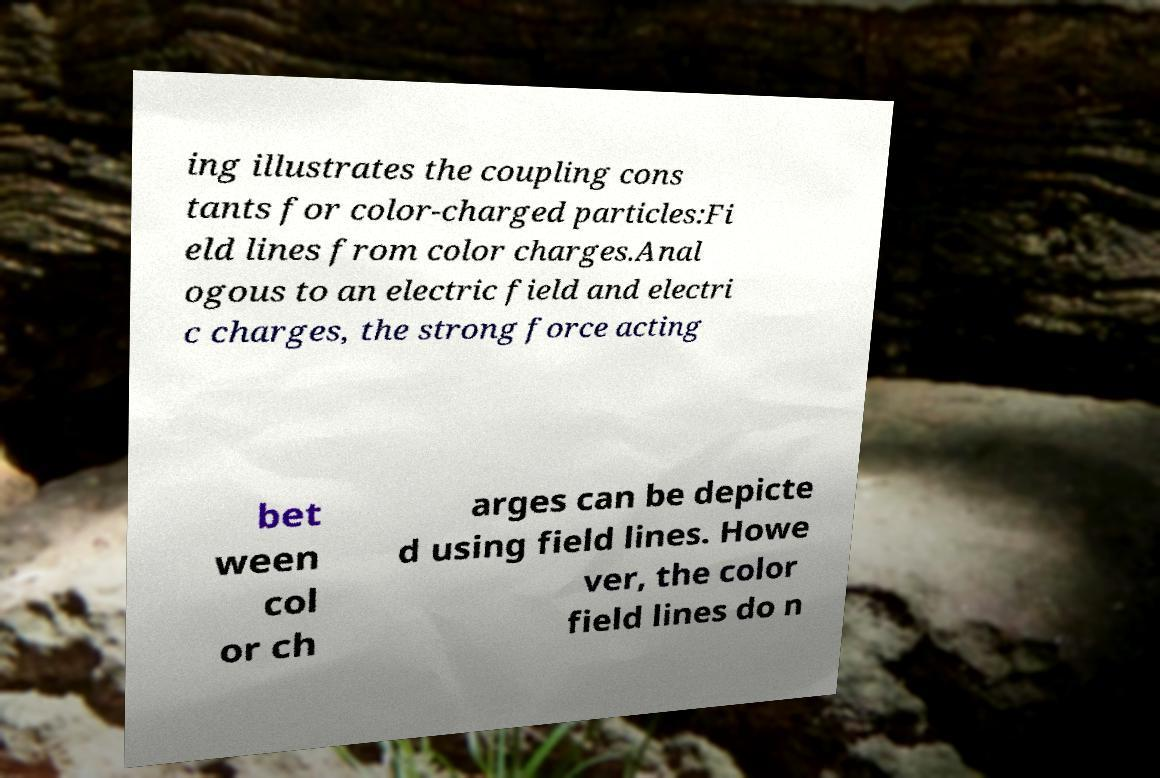Could you extract and type out the text from this image? ing illustrates the coupling cons tants for color-charged particles:Fi eld lines from color charges.Anal ogous to an electric field and electri c charges, the strong force acting bet ween col or ch arges can be depicte d using field lines. Howe ver, the color field lines do n 